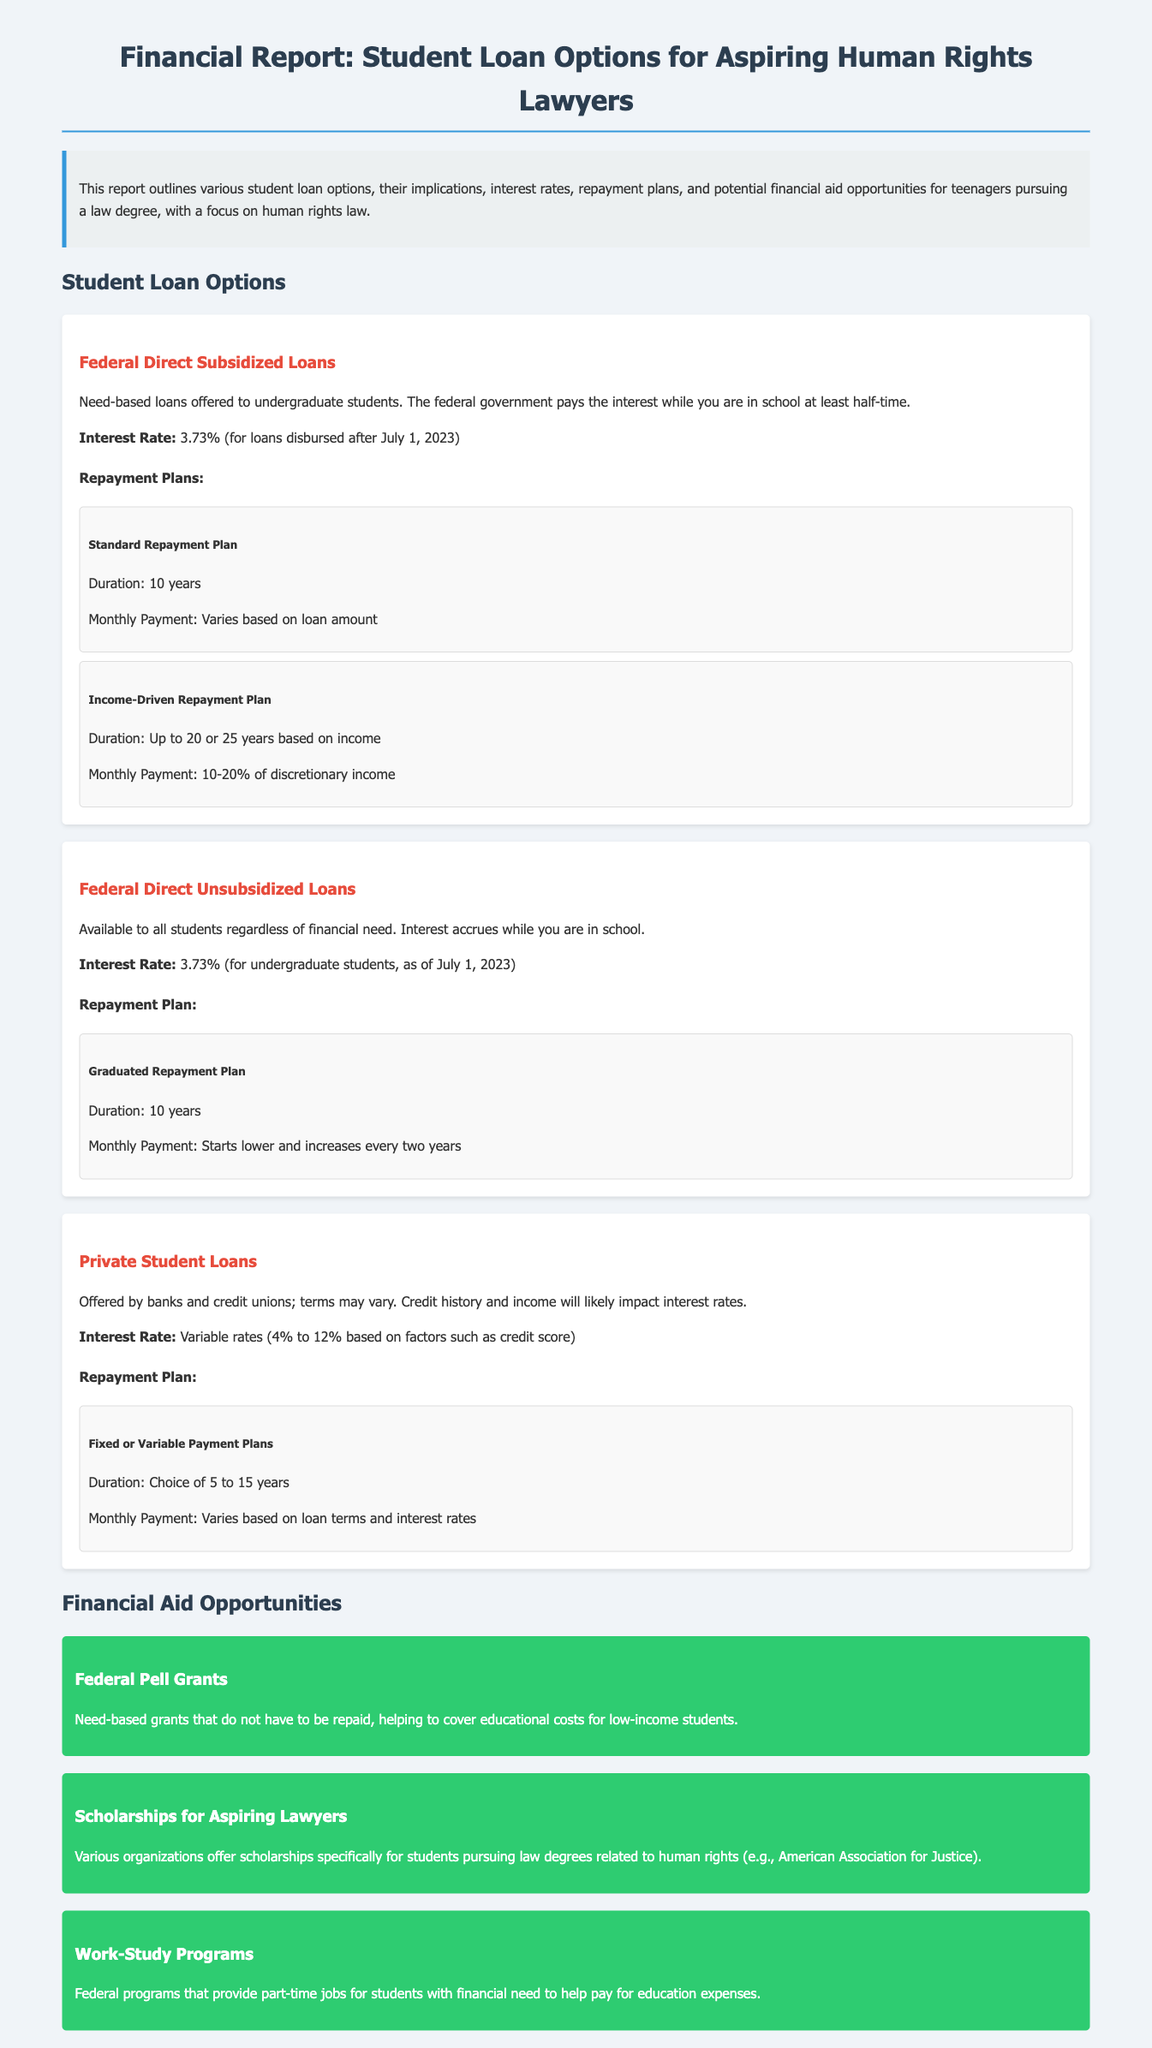What is the interest rate for Federal Direct Subsidized Loans? The interest rate for Federal Direct Subsidized Loans is specified in the document as 3.73% for loans disbursed after July 1, 2023.
Answer: 3.73% What is the repayment duration for the Graduated Repayment Plan? The repayment duration for the Graduated Repayment Plan is mentioned in the document as 10 years.
Answer: 10 years What type of loans are Federal Direct Unsubsidized Loans? The document describes Federal Direct Unsubsidized Loans as available to all students regardless of financial need.
Answer: Available to all students What percent of discretionary income is paid in the Income-Driven Repayment Plan? The document states that the Income-Driven Repayment Plan requires a payment of 10-20% of discretionary income.
Answer: 10-20% What kind of grants are Federal Pell Grants? The document classifies Federal Pell Grants as need-based grants that do not have to be repaid.
Answer: Need-based grants What options are available for Private Student Loans' interest rates? The document mentions that Private Student Loans have variable rates from 4% to 12% based on factors such as credit score.
Answer: 4% to 12% Which organization offers scholarships specifically related to human rights law? The document mentions the American Association for Justice as an organization providing scholarships for students pursuing law degrees related to human rights.
Answer: American Association for Justice What is the repayment plan for Federal Direct Subsidized Loans? The document lists two repayment plans: Standard Repayment Plan and Income-Driven Repayment Plan for Federal Direct Subsidized Loans.
Answer: Two plans 